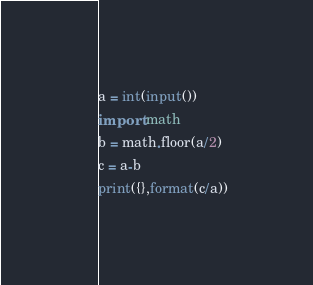Convert code to text. <code><loc_0><loc_0><loc_500><loc_500><_Python_>a = int(input())
import math
b = math.floor(a/2)
c = a-b
print({},format(c/a))
</code> 